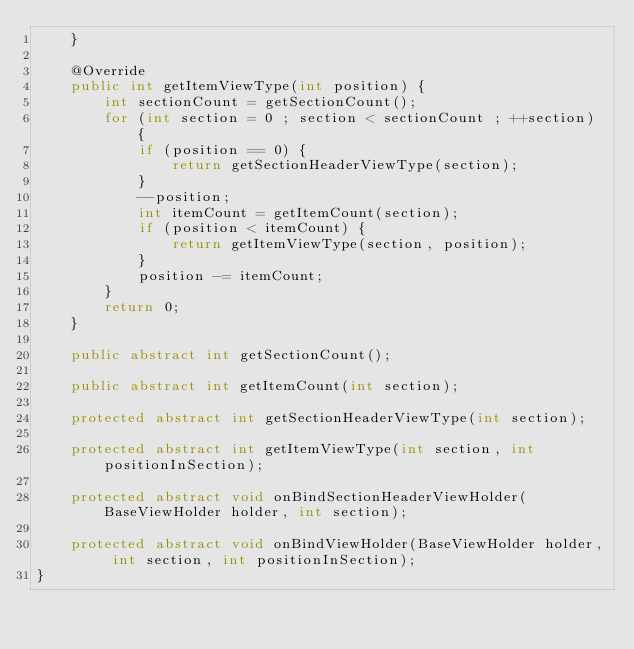Convert code to text. <code><loc_0><loc_0><loc_500><loc_500><_Java_>    }

    @Override
    public int getItemViewType(int position) {
        int sectionCount = getSectionCount();
        for (int section = 0 ; section < sectionCount ; ++section) {
            if (position == 0) {
                return getSectionHeaderViewType(section);
            }
            --position;
            int itemCount = getItemCount(section);
            if (position < itemCount) {
                return getItemViewType(section, position);
            }
            position -= itemCount;
        }
        return 0;
    }

    public abstract int getSectionCount();

    public abstract int getItemCount(int section);

    protected abstract int getSectionHeaderViewType(int section);

    protected abstract int getItemViewType(int section, int positionInSection);

    protected abstract void onBindSectionHeaderViewHolder(BaseViewHolder holder, int section);

    protected abstract void onBindViewHolder(BaseViewHolder holder, int section, int positionInSection);
}
</code> 